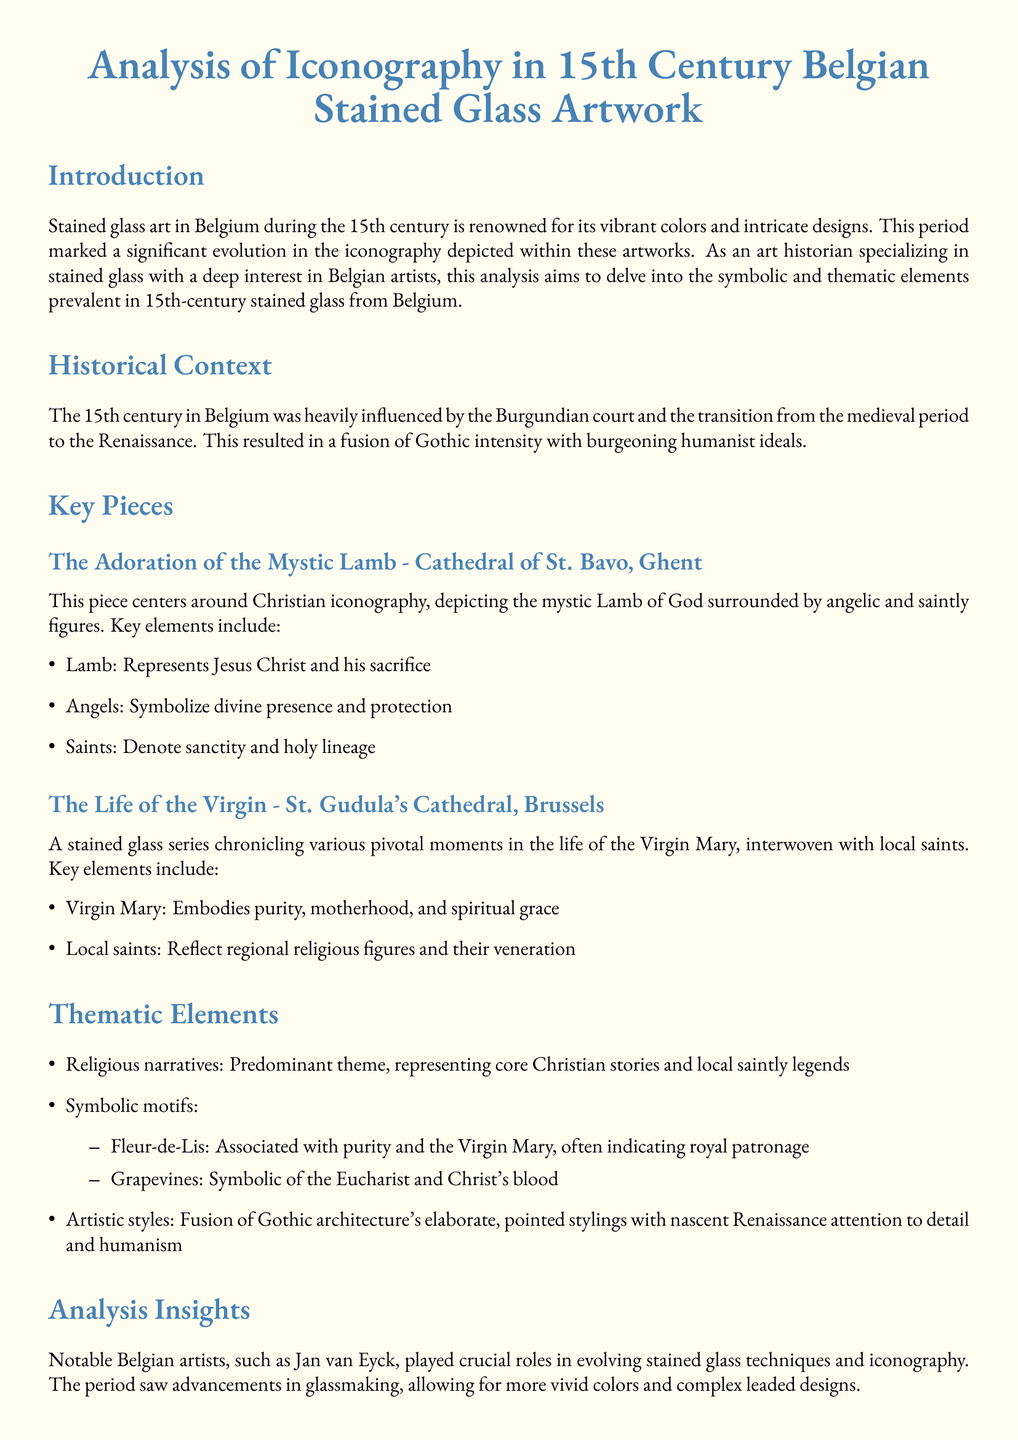What is the title of the document? The title is prominently displayed at the beginning of the document, highlighting the subject matter.
Answer: Analysis of Iconography in 15th Century Belgian Stained Glass Artwork Who created "The Adoration of the Mystic Lamb"? The document refers to this piece as being located in the Cathedral of St. Bavo, Ghent but does not specify the artist.
Answer: Unknown What does the Lamb represent in "The Adoration of the Mystic Lamb"? The text explains that the Lamb symbolizes Jesus Christ and his sacrifice within the piece's iconography.
Answer: Jesus Christ What key theme is predominant in 15th-century Belgian stained glass artworks? The document outlines a major theme as religious narratives, indicating its significance in the artwork of the period.
Answer: Religious narratives What does the Fleur-de-Lis symbolize in the thematic elements? The document states that the Fleur-de-Lis is associated with purity and the Virgin Mary, indicating its broader significance.
Answer: Purity Which cathedral features the stained glass series about the life of the Virgin Mary? The document specifically mentions this stained glass series is located in St. Gudula's Cathedral, Brussels.
Answer: St. Gudula's Cathedral What advancements did Belgian artists bring to stained glass during the 15th century? The analysis notes that there were advancements in glassmaking, allowing for more vivid colors and complex designs.
Answer: Glassmaking What cultural influences are mentioned in the historical context section? The document cites the Burgundian court and the transition from the medieval period to the Renaissance as significant influences.
Answer: Burgundian court What is suggested as a future research direction regarding Belgian stained glass? The conclusion proposes comparative analysis with contemporary stained glass works from other regions or detailed studies of individual artists.
Answer: Comparative analysis 